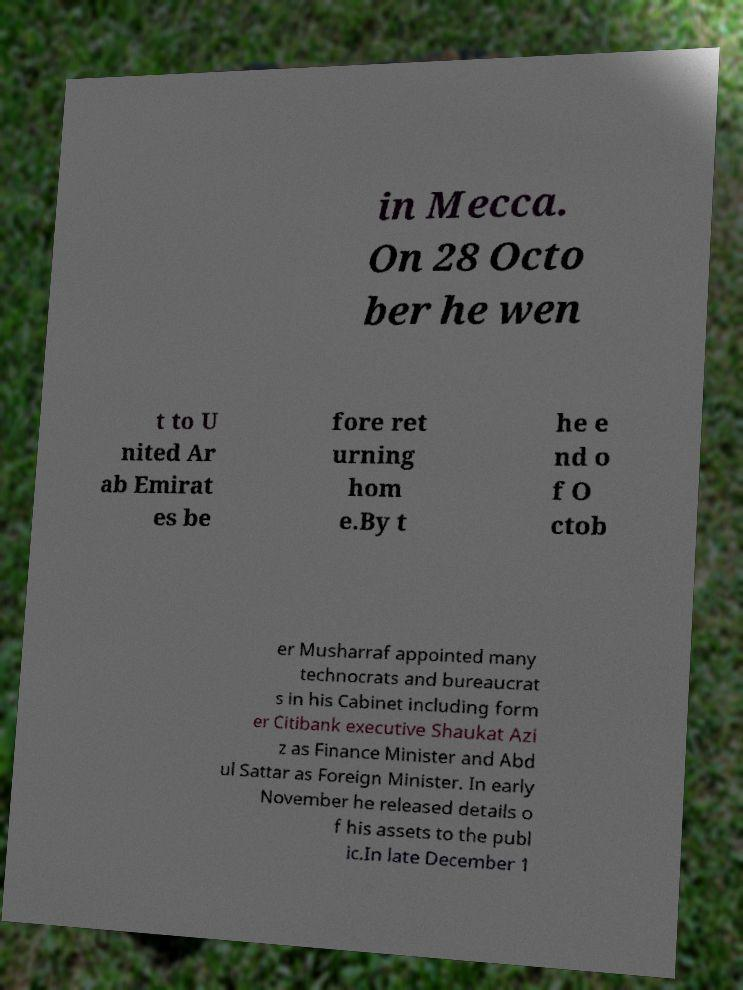Please identify and transcribe the text found in this image. in Mecca. On 28 Octo ber he wen t to U nited Ar ab Emirat es be fore ret urning hom e.By t he e nd o f O ctob er Musharraf appointed many technocrats and bureaucrat s in his Cabinet including form er Citibank executive Shaukat Azi z as Finance Minister and Abd ul Sattar as Foreign Minister. In early November he released details o f his assets to the publ ic.In late December 1 